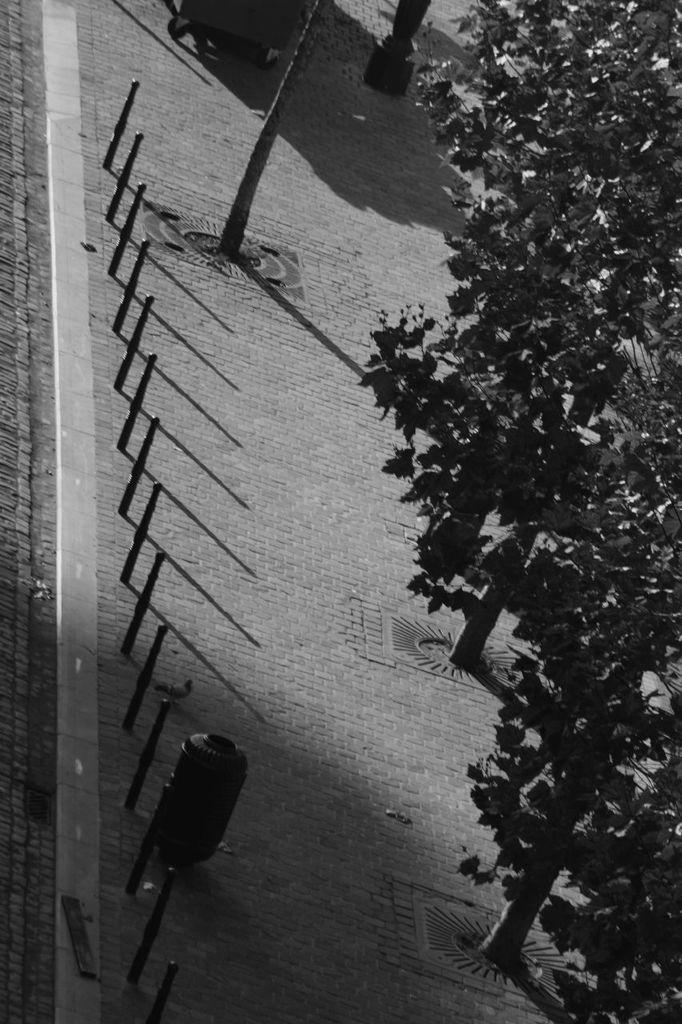What type of vegetation is on the right side of the image? There are trees on the right side of the image. What object can be seen in the image besides the trees? There is a pole in the image. Who is leading the committee in the image? There is no committee present in the image. What type of operation is being performed on the mother in the image? There is no mother or operation present in the image. 